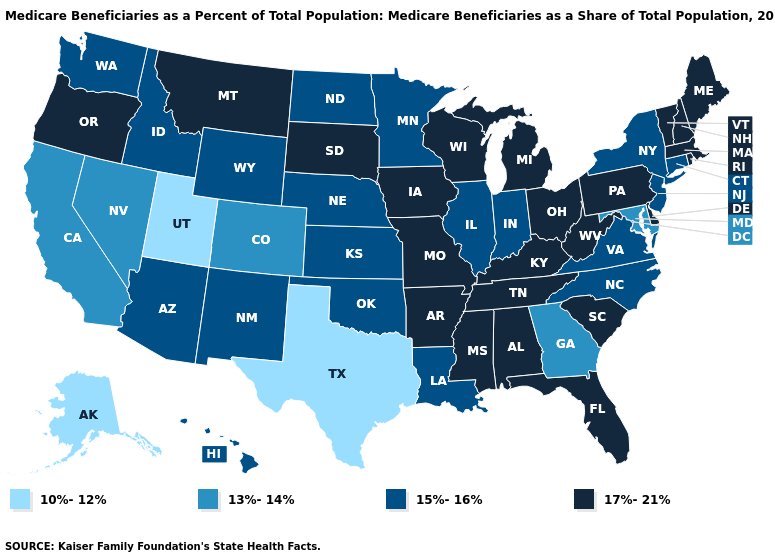Does Indiana have a higher value than Florida?
Be succinct. No. Name the states that have a value in the range 15%-16%?
Short answer required. Arizona, Connecticut, Hawaii, Idaho, Illinois, Indiana, Kansas, Louisiana, Minnesota, Nebraska, New Jersey, New Mexico, New York, North Carolina, North Dakota, Oklahoma, Virginia, Washington, Wyoming. Which states hav the highest value in the MidWest?
Answer briefly. Iowa, Michigan, Missouri, Ohio, South Dakota, Wisconsin. Does the map have missing data?
Short answer required. No. What is the highest value in the Northeast ?
Answer briefly. 17%-21%. Name the states that have a value in the range 13%-14%?
Keep it brief. California, Colorado, Georgia, Maryland, Nevada. How many symbols are there in the legend?
Concise answer only. 4. What is the lowest value in states that border Virginia?
Quick response, please. 13%-14%. Does Arizona have a higher value than Colorado?
Quick response, please. Yes. Which states have the lowest value in the USA?
Quick response, please. Alaska, Texas, Utah. Does Tennessee have a higher value than New York?
Write a very short answer. Yes. How many symbols are there in the legend?
Quick response, please. 4. Which states have the lowest value in the USA?
Quick response, please. Alaska, Texas, Utah. Does Alabama have the lowest value in the USA?
Concise answer only. No. 